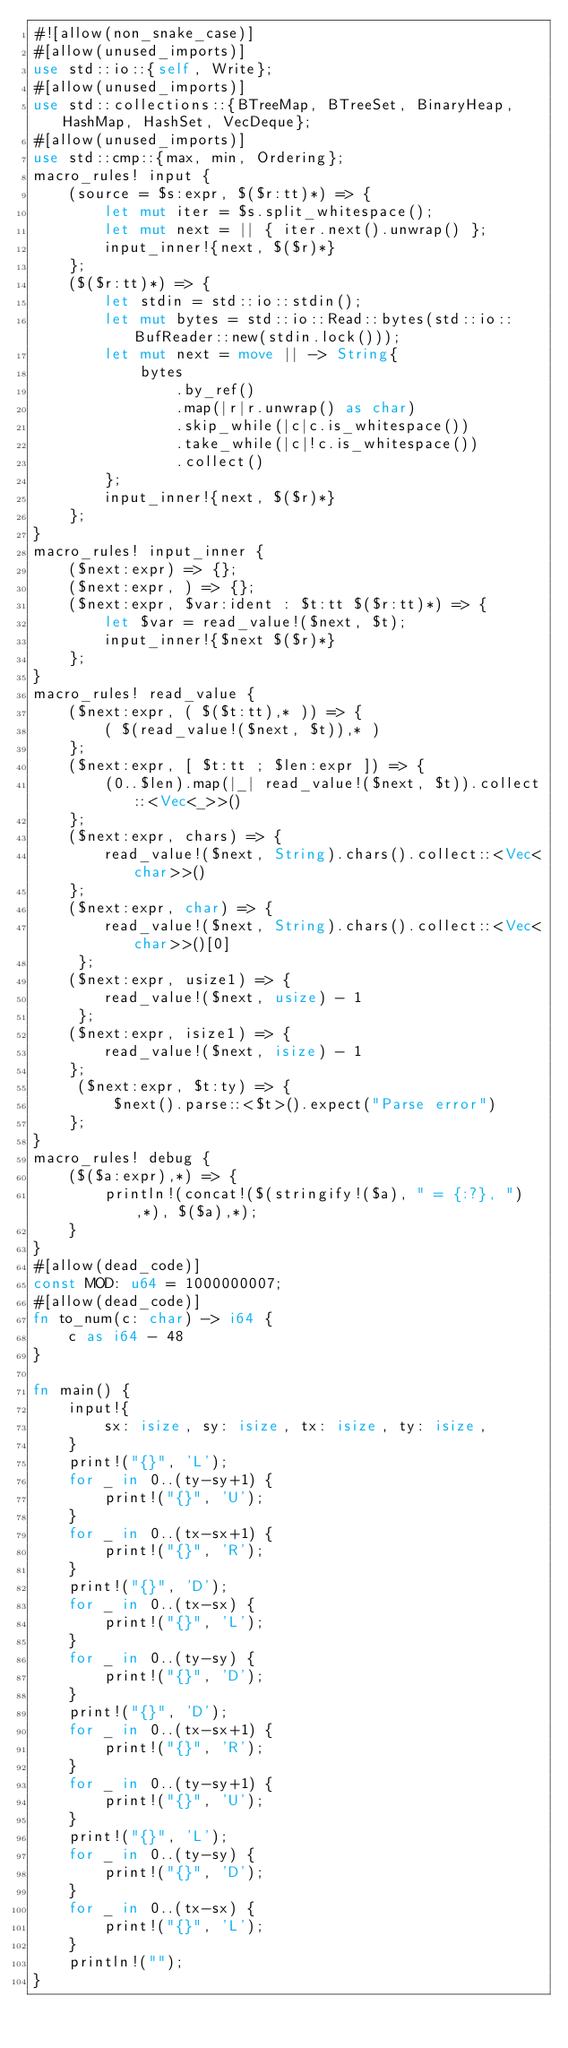<code> <loc_0><loc_0><loc_500><loc_500><_Rust_>#![allow(non_snake_case)]
#[allow(unused_imports)]
use std::io::{self, Write};
#[allow(unused_imports)]
use std::collections::{BTreeMap, BTreeSet, BinaryHeap, HashMap, HashSet, VecDeque};
#[allow(unused_imports)]
use std::cmp::{max, min, Ordering};
macro_rules! input {
    (source = $s:expr, $($r:tt)*) => {
        let mut iter = $s.split_whitespace();
        let mut next = || { iter.next().unwrap() };
        input_inner!{next, $($r)*}
    };
    ($($r:tt)*) => {
        let stdin = std::io::stdin();
        let mut bytes = std::io::Read::bytes(std::io::BufReader::new(stdin.lock()));
        let mut next = move || -> String{
            bytes
                .by_ref()
                .map(|r|r.unwrap() as char)
                .skip_while(|c|c.is_whitespace())
                .take_while(|c|!c.is_whitespace())
                .collect()
        };
        input_inner!{next, $($r)*}
    };
}
macro_rules! input_inner {
    ($next:expr) => {};
    ($next:expr, ) => {};
    ($next:expr, $var:ident : $t:tt $($r:tt)*) => {
        let $var = read_value!($next, $t);
        input_inner!{$next $($r)*}
    };
}
macro_rules! read_value {
    ($next:expr, ( $($t:tt),* )) => {
        ( $(read_value!($next, $t)),* )
    };
    ($next:expr, [ $t:tt ; $len:expr ]) => {
        (0..$len).map(|_| read_value!($next, $t)).collect::<Vec<_>>()
    };
    ($next:expr, chars) => {
        read_value!($next, String).chars().collect::<Vec<char>>()
    };
    ($next:expr, char) => {
        read_value!($next, String).chars().collect::<Vec<char>>()[0]
     };
    ($next:expr, usize1) => {
        read_value!($next, usize) - 1
     };
    ($next:expr, isize1) => {
        read_value!($next, isize) - 1
    };
     ($next:expr, $t:ty) => {
         $next().parse::<$t>().expect("Parse error")
    };
}
macro_rules! debug {
    ($($a:expr),*) => {
        println!(concat!($(stringify!($a), " = {:?}, "),*), $($a),*);
    }
}
#[allow(dead_code)]
const MOD: u64 = 1000000007;
#[allow(dead_code)]
fn to_num(c: char) -> i64 {
    c as i64 - 48
}

fn main() {
    input!{
        sx: isize, sy: isize, tx: isize, ty: isize,
    }
    print!("{}", 'L');
    for _ in 0..(ty-sy+1) {
        print!("{}", 'U');
    }
    for _ in 0..(tx-sx+1) {
        print!("{}", 'R');
    }
    print!("{}", 'D');
    for _ in 0..(tx-sx) {
        print!("{}", 'L');
    }
    for _ in 0..(ty-sy) {
        print!("{}", 'D');
    }
    print!("{}", 'D');
    for _ in 0..(tx-sx+1) {
        print!("{}", 'R');
    }
    for _ in 0..(ty-sy+1) {
        print!("{}", 'U');
    }
    print!("{}", 'L');
    for _ in 0..(ty-sy) {
        print!("{}", 'D');
    }
    for _ in 0..(tx-sx) {
        print!("{}", 'L');
    }
    println!("");
}
</code> 